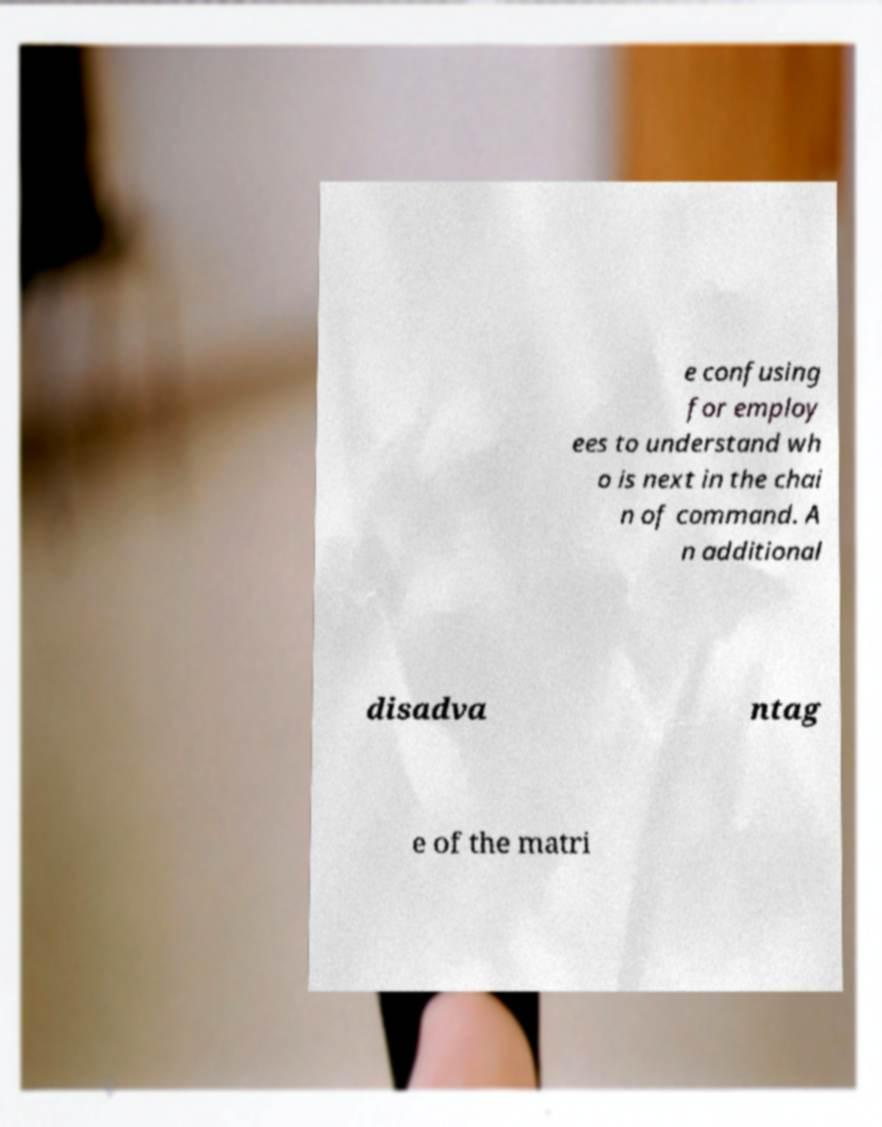Please identify and transcribe the text found in this image. e confusing for employ ees to understand wh o is next in the chai n of command. A n additional disadva ntag e of the matri 